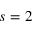Convert formula to latex. <formula><loc_0><loc_0><loc_500><loc_500>s = 2</formula> 